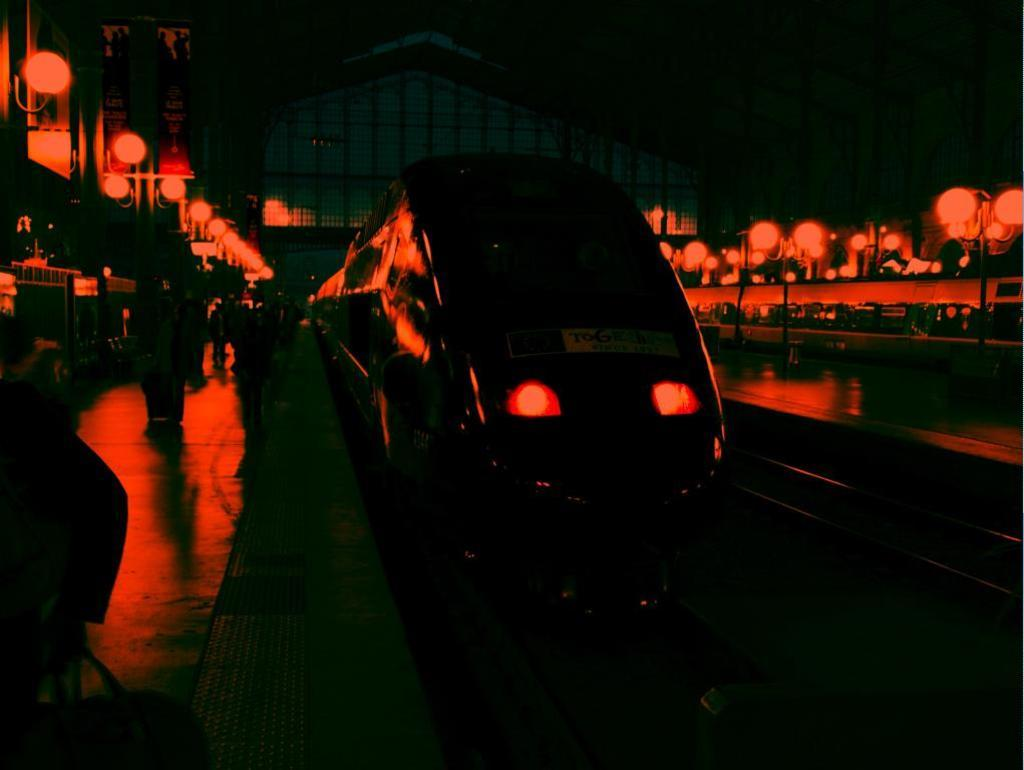What is the main subject of the image? The main subject of the image is a train. What can be seen on the left side of the image? There is a platform on the left side of the image. What are the people near the train or platform doing? The people standing near the train or platform are likely waiting for the train or disembarking from it. What else is visible in the image besides the train and platform? There are lights visible in the image. Can you tell me how many kittens are playing on the amusement ride in the image? There are no kittens or amusement rides present in the image; it features a train and a platform. What type of cheese is being served to the people near the train in the image? There is no cheese visible in the image, and it does not appear that any food is being served. 